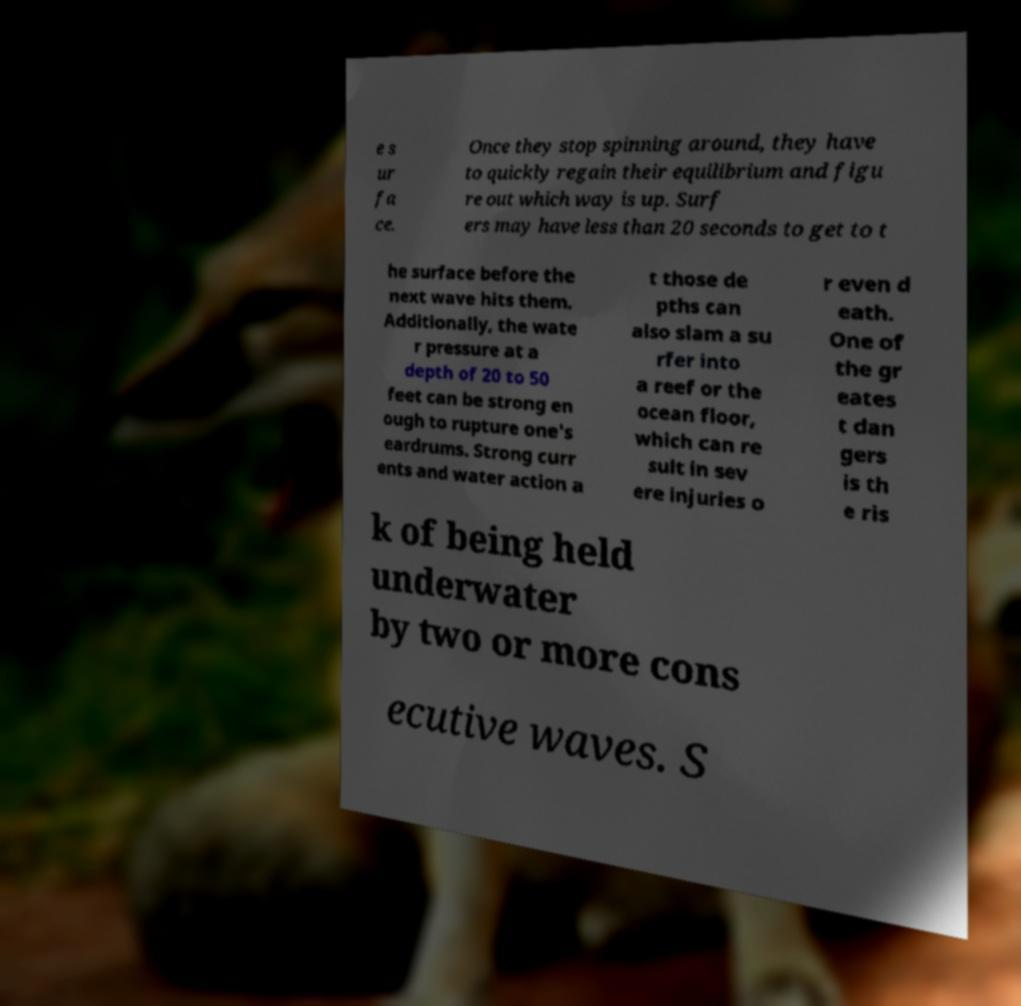Can you read and provide the text displayed in the image?This photo seems to have some interesting text. Can you extract and type it out for me? e s ur fa ce. Once they stop spinning around, they have to quickly regain their equilibrium and figu re out which way is up. Surf ers may have less than 20 seconds to get to t he surface before the next wave hits them. Additionally, the wate r pressure at a depth of 20 to 50 feet can be strong en ough to rupture one's eardrums. Strong curr ents and water action a t those de pths can also slam a su rfer into a reef or the ocean floor, which can re sult in sev ere injuries o r even d eath. One of the gr eates t dan gers is th e ris k of being held underwater by two or more cons ecutive waves. S 